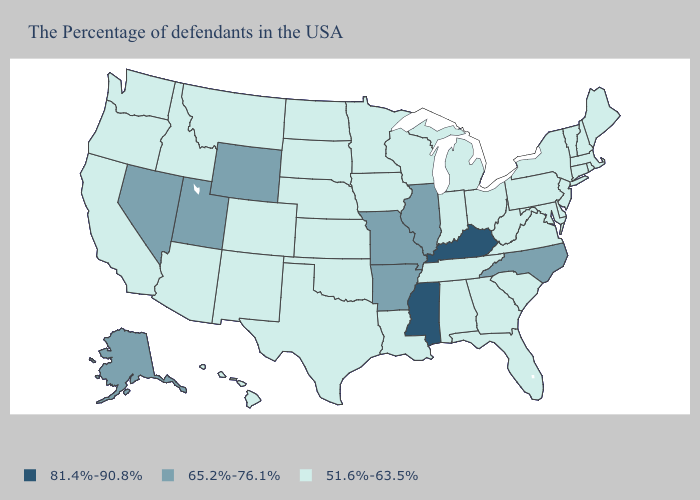Name the states that have a value in the range 65.2%-76.1%?
Concise answer only. North Carolina, Illinois, Missouri, Arkansas, Wyoming, Utah, Nevada, Alaska. Does Missouri have the same value as North Dakota?
Answer briefly. No. Which states have the lowest value in the South?
Quick response, please. Delaware, Maryland, Virginia, South Carolina, West Virginia, Florida, Georgia, Alabama, Tennessee, Louisiana, Oklahoma, Texas. What is the value of South Dakota?
Write a very short answer. 51.6%-63.5%. What is the value of South Carolina?
Write a very short answer. 51.6%-63.5%. What is the value of West Virginia?
Give a very brief answer. 51.6%-63.5%. What is the highest value in the USA?
Be succinct. 81.4%-90.8%. Does Virginia have a lower value than Maine?
Give a very brief answer. No. Name the states that have a value in the range 81.4%-90.8%?
Be succinct. Kentucky, Mississippi. Among the states that border Illinois , does Wisconsin have the lowest value?
Give a very brief answer. Yes. Does the first symbol in the legend represent the smallest category?
Give a very brief answer. No. Does Arkansas have the same value as Wyoming?
Concise answer only. Yes. Does Kentucky have the highest value in the USA?
Keep it brief. Yes. What is the value of Ohio?
Write a very short answer. 51.6%-63.5%. 